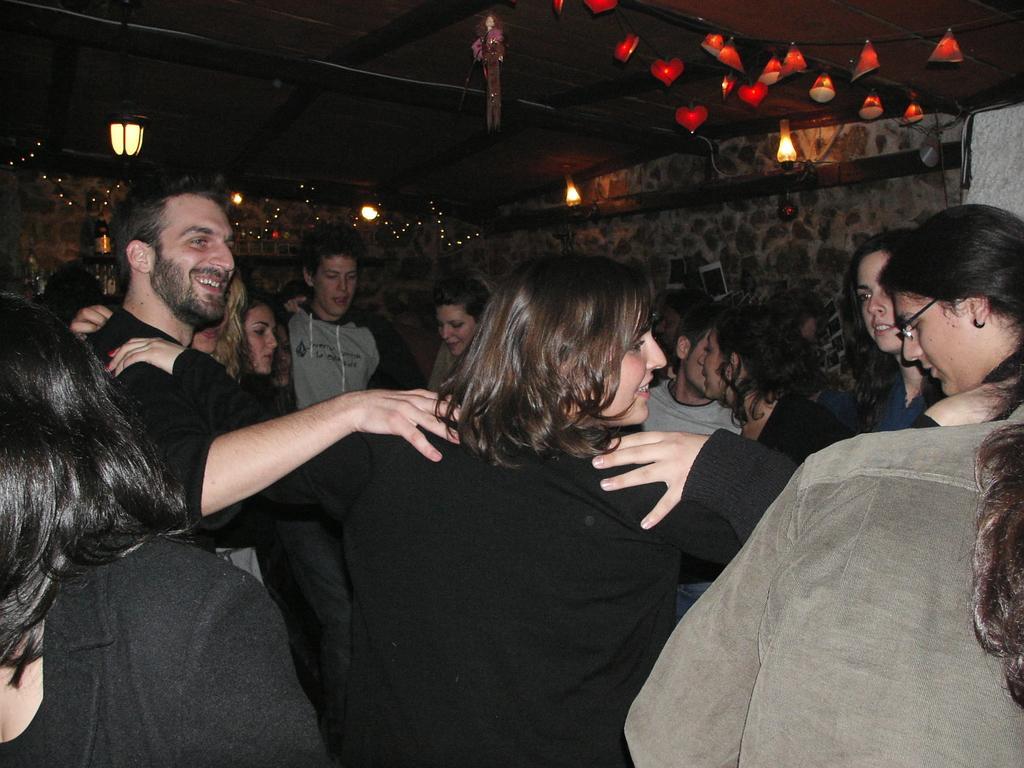Describe this image in one or two sentences. In this picture we can see a group of people on the path and behind the people there is a wall and at the top there are decorative lights. 